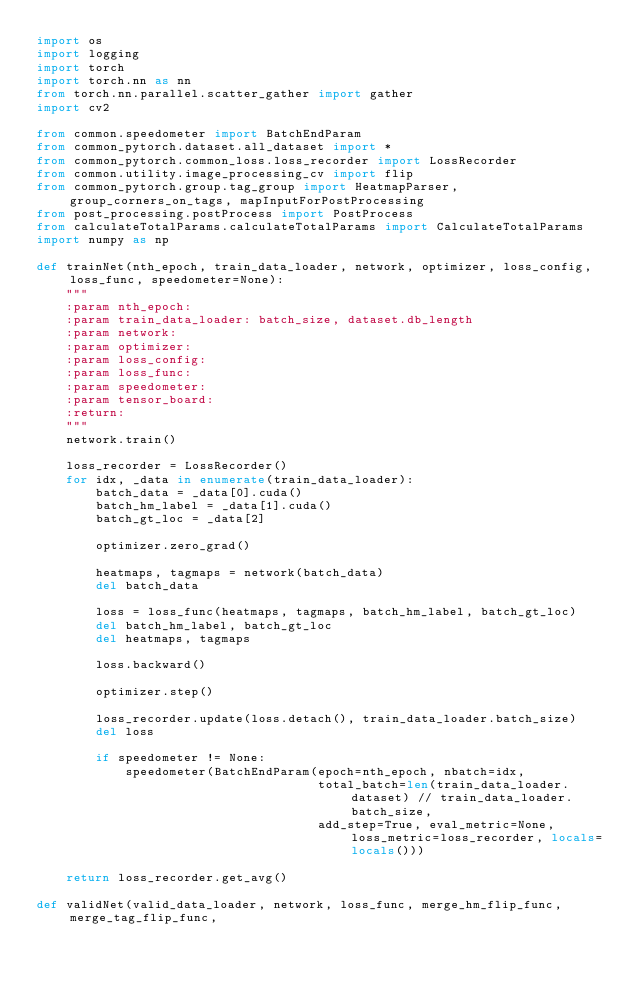Convert code to text. <code><loc_0><loc_0><loc_500><loc_500><_Python_>import os
import logging
import torch
import torch.nn as nn
from torch.nn.parallel.scatter_gather import gather
import cv2

from common.speedometer import BatchEndParam
from common_pytorch.dataset.all_dataset import *
from common_pytorch.common_loss.loss_recorder import LossRecorder
from common.utility.image_processing_cv import flip
from common_pytorch.group.tag_group import HeatmapParser, group_corners_on_tags, mapInputForPostProcessing
from post_processing.postProcess import PostProcess
from calculateTotalParams.calculateTotalParams import CalculateTotalParams
import numpy as np

def trainNet(nth_epoch, train_data_loader, network, optimizer, loss_config, loss_func, speedometer=None):
    """
    :param nth_epoch:
    :param train_data_loader: batch_size, dataset.db_length
    :param network:
    :param optimizer:
    :param loss_config:
    :param loss_func:
    :param speedometer:
    :param tensor_board:
    :return:
    """
    network.train()

    loss_recorder = LossRecorder()
    for idx, _data in enumerate(train_data_loader):
        batch_data = _data[0].cuda()
        batch_hm_label = _data[1].cuda()
        batch_gt_loc = _data[2]

        optimizer.zero_grad()

        heatmaps, tagmaps = network(batch_data)
        del batch_data

        loss = loss_func(heatmaps, tagmaps, batch_hm_label, batch_gt_loc)
        del batch_hm_label, batch_gt_loc
        del heatmaps, tagmaps

        loss.backward()

        optimizer.step()

        loss_recorder.update(loss.detach(), train_data_loader.batch_size)
        del loss

        if speedometer != None:
            speedometer(BatchEndParam(epoch=nth_epoch, nbatch=idx,
                                      total_batch=len(train_data_loader.dataset) // train_data_loader.batch_size,
                                      add_step=True, eval_metric=None, loss_metric=loss_recorder, locals=locals()))

    return loss_recorder.get_avg()

def validNet(valid_data_loader, network, loss_func, merge_hm_flip_func, merge_tag_flip_func,</code> 